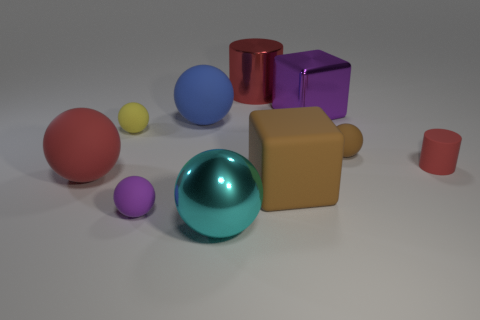Subtract all large red balls. How many balls are left? 5 Subtract 4 spheres. How many spheres are left? 2 Subtract all red spheres. How many spheres are left? 5 Subtract all spheres. How many objects are left? 4 Add 7 tiny brown balls. How many tiny brown balls exist? 8 Subtract 0 cyan blocks. How many objects are left? 10 Subtract all blue spheres. Subtract all green cylinders. How many spheres are left? 5 Subtract all cyan spheres. Subtract all large cylinders. How many objects are left? 8 Add 7 brown matte things. How many brown matte things are left? 9 